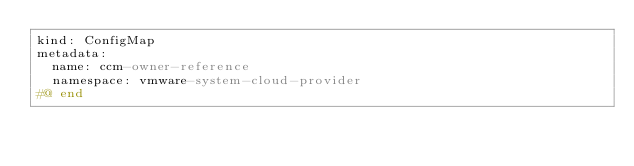<code> <loc_0><loc_0><loc_500><loc_500><_YAML_>kind: ConfigMap
metadata:
  name: ccm-owner-reference
  namespace: vmware-system-cloud-provider
#@ end
</code> 